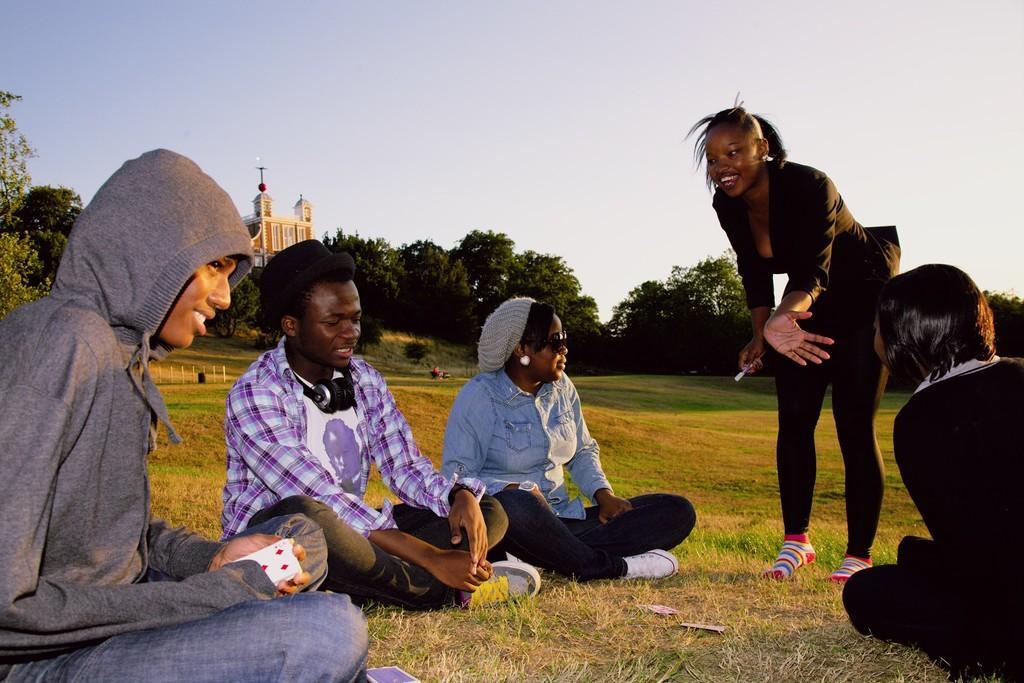Describe this image in one or two sentences. In the picture we can see some people are sitting on the grass surface and one woman is standing and bending and showing her palm to others who are sitting and in the background we can see some trees, building and sky. 